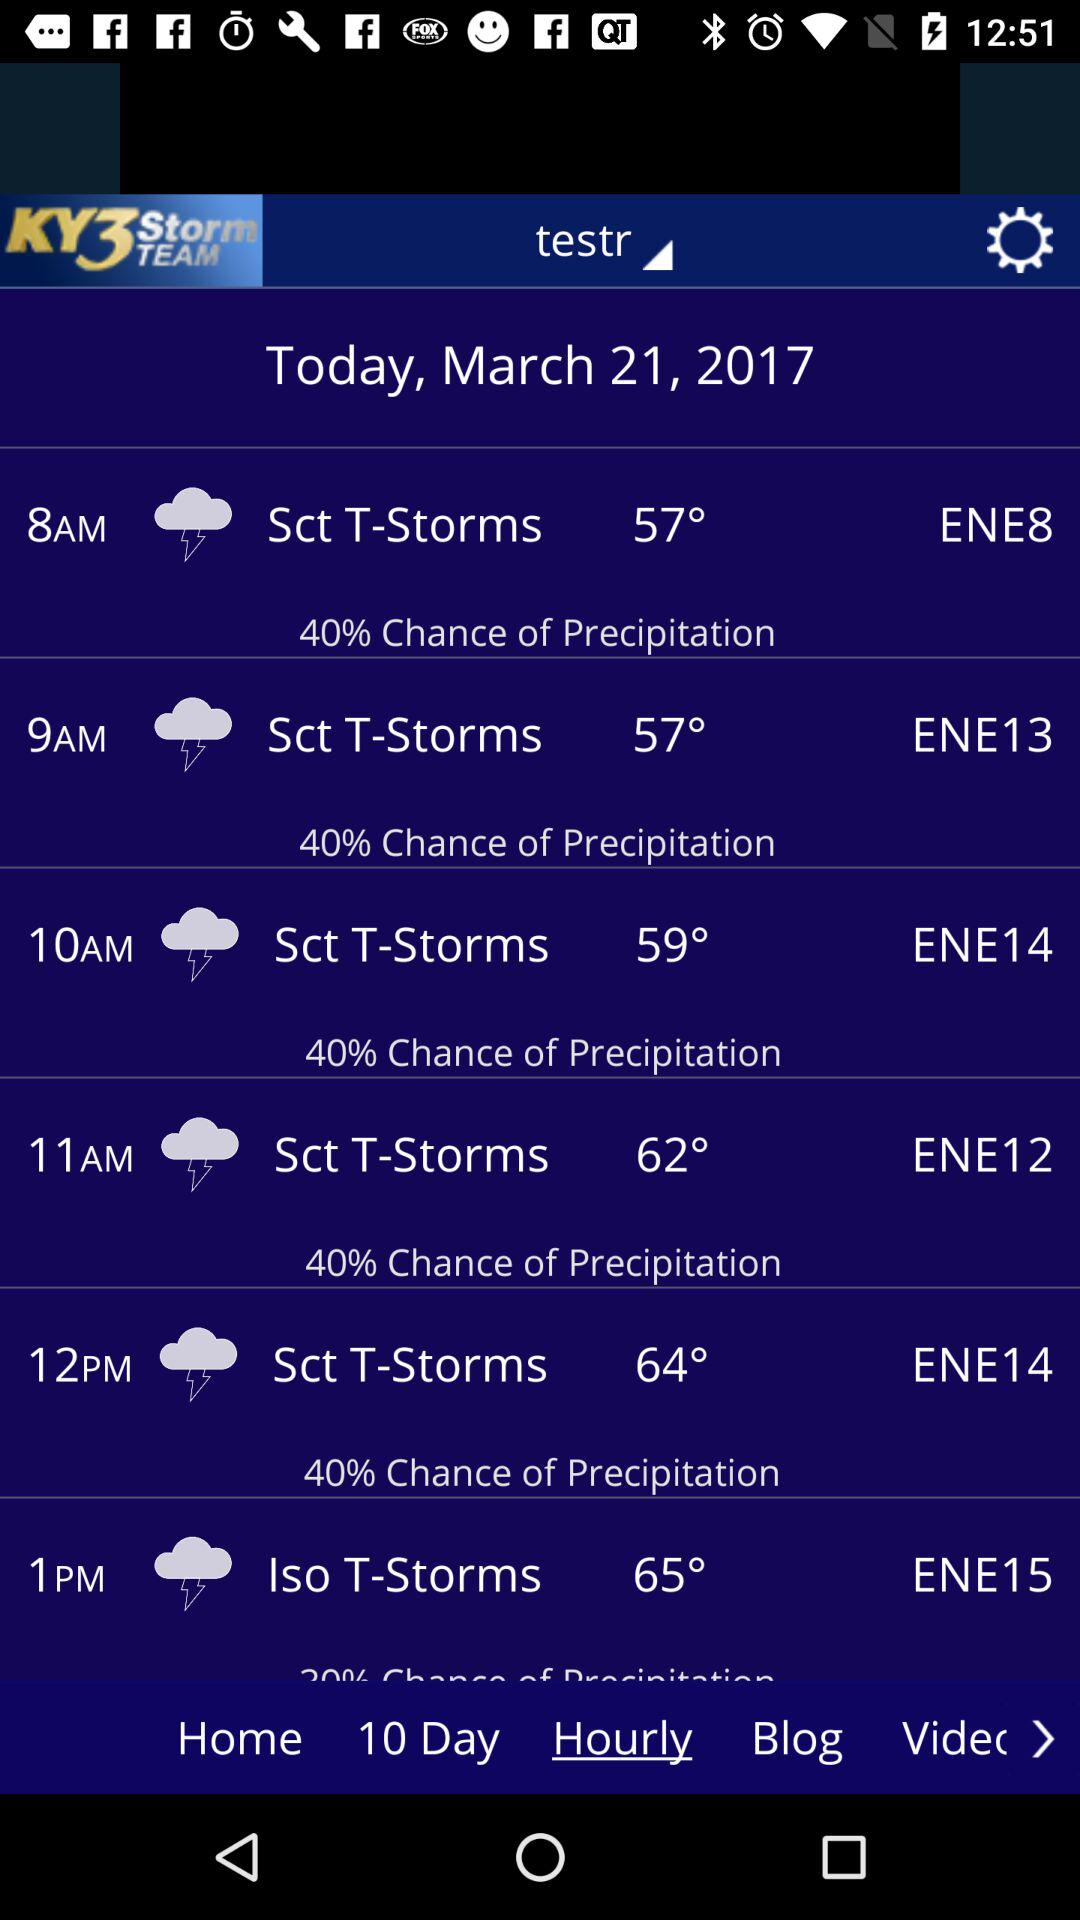What is the percentage chance of precipitation for the 11am hour?
Answer the question using a single word or phrase. 40% 